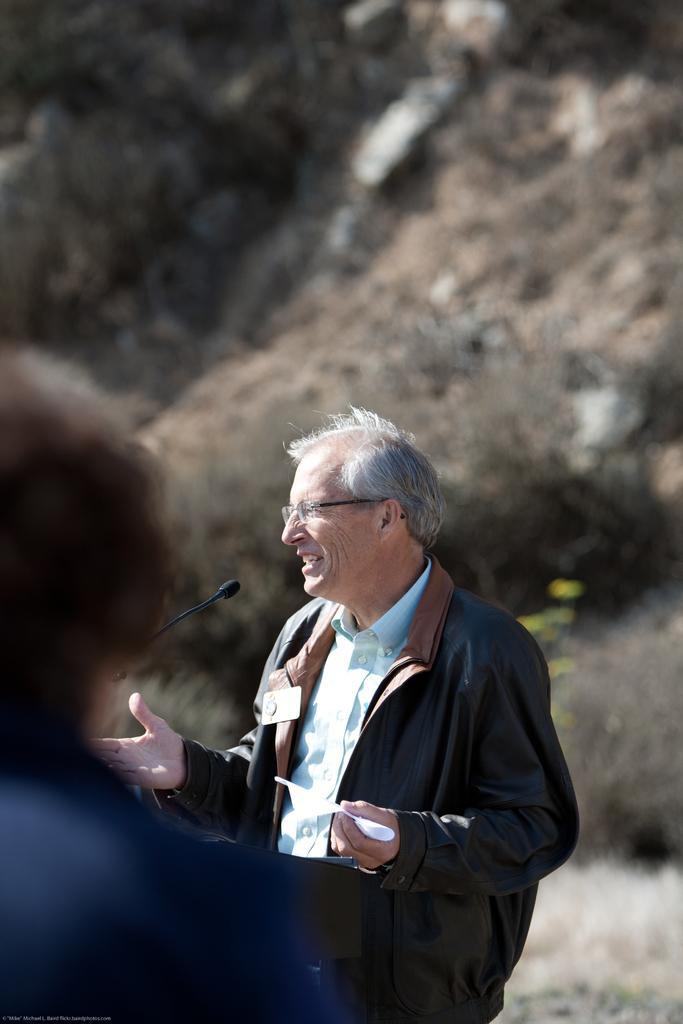How many people are in the image? There are two people in the image. What are the people wearing? The people are wearing different color dresses. What object is in front of one of the people? There is a mic in front of one person. What can be seen in the background of the image? There are trees in the background of the image. How is the background of the image depicted? The background is blurred. What type of weather can be seen in the image? The provided facts do not mention any weather conditions, so it cannot be determined from the image. 